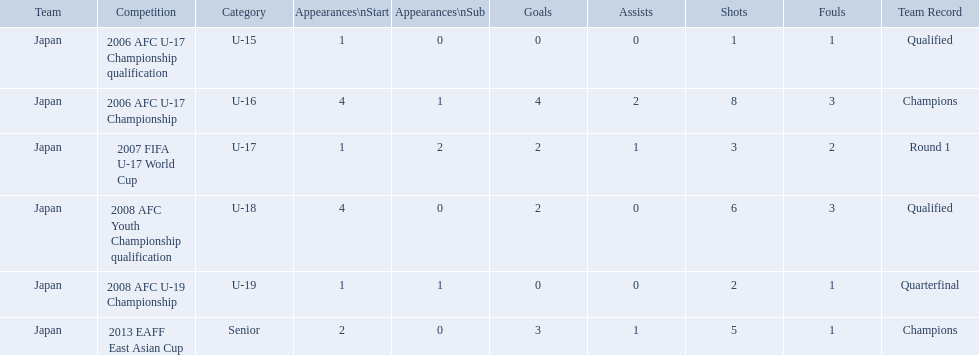Which competitions had champions team records? 2006 AFC U-17 Championship, 2013 EAFF East Asian Cup. Parse the full table in json format. {'header': ['Team', 'Competition', 'Category', 'Appearances\\nStart', 'Appearances\\nSub', 'Goals', 'Assists', 'Shots', 'Fouls', 'Team Record'], 'rows': [['Japan', '2006 AFC U-17 Championship qualification', 'U-15', '1', '0', '0', '0', '1', '1', 'Qualified'], ['Japan', '2006 AFC U-17 Championship', 'U-16', '4', '1', '4', '2', '8', '3', 'Champions'], ['Japan', '2007 FIFA U-17 World Cup', 'U-17', '1', '2', '2', '1', '3', '2', 'Round 1'], ['Japan', '2008 AFC Youth Championship qualification', 'U-18', '4', '0', '2', '0', '6', '3', 'Qualified'], ['Japan', '2008 AFC U-19 Championship', 'U-19', '1', '1', '0', '0', '2', '1', 'Quarterfinal'], ['Japan', '2013 EAFF East Asian Cup', 'Senior', '2', '0', '3', '1', '5', '1', 'Champions']]} Of these competitions, which one was in the senior category? 2013 EAFF East Asian Cup. 